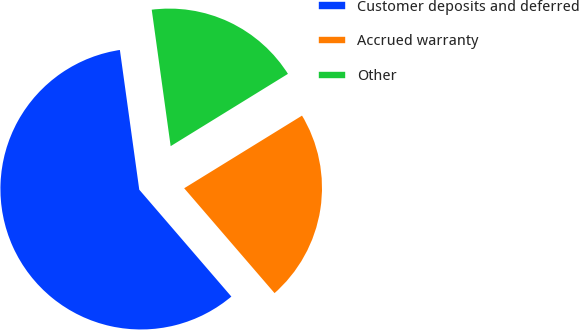Convert chart. <chart><loc_0><loc_0><loc_500><loc_500><pie_chart><fcel>Customer deposits and deferred<fcel>Accrued warranty<fcel>Other<nl><fcel>59.12%<fcel>22.47%<fcel>18.4%<nl></chart> 